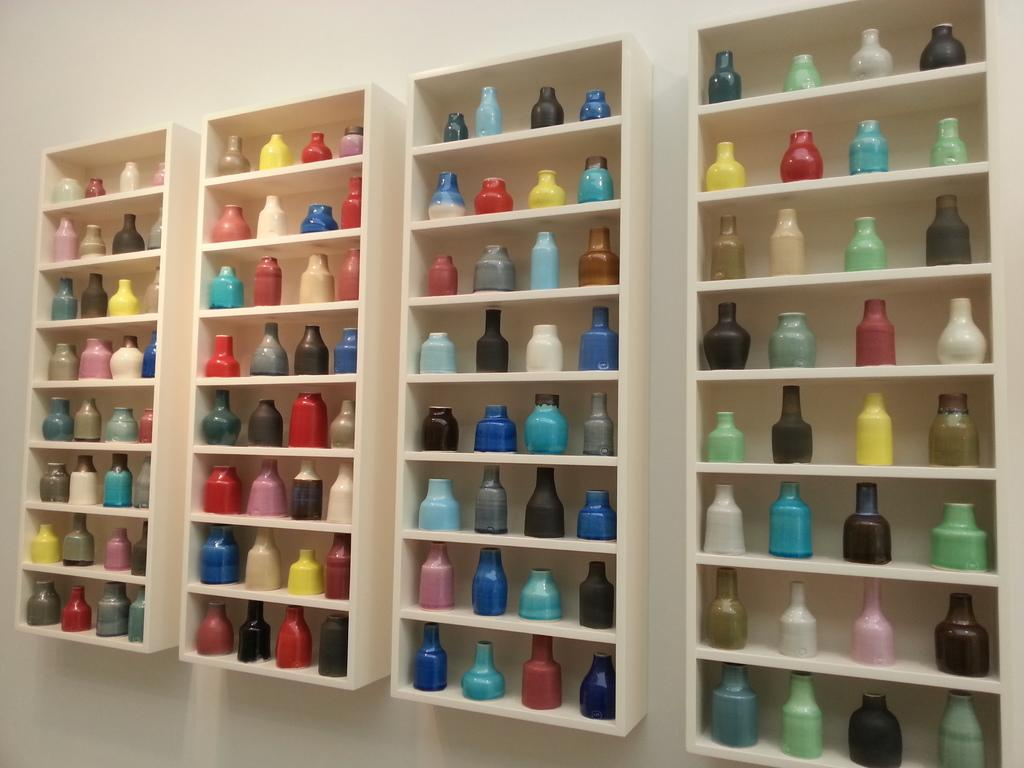What objects are present in the image? There are bottles in the image. How are the bottles arranged? The bottles are in racks. What can be seen in the background of the image? There is a wall visible in the background of the image. What type of note is written on the wall in the image? There is no note written on the wall in the image. What riddle can be solved by looking at the bottles in the image? There is no riddle associated with the bottles in the image. 